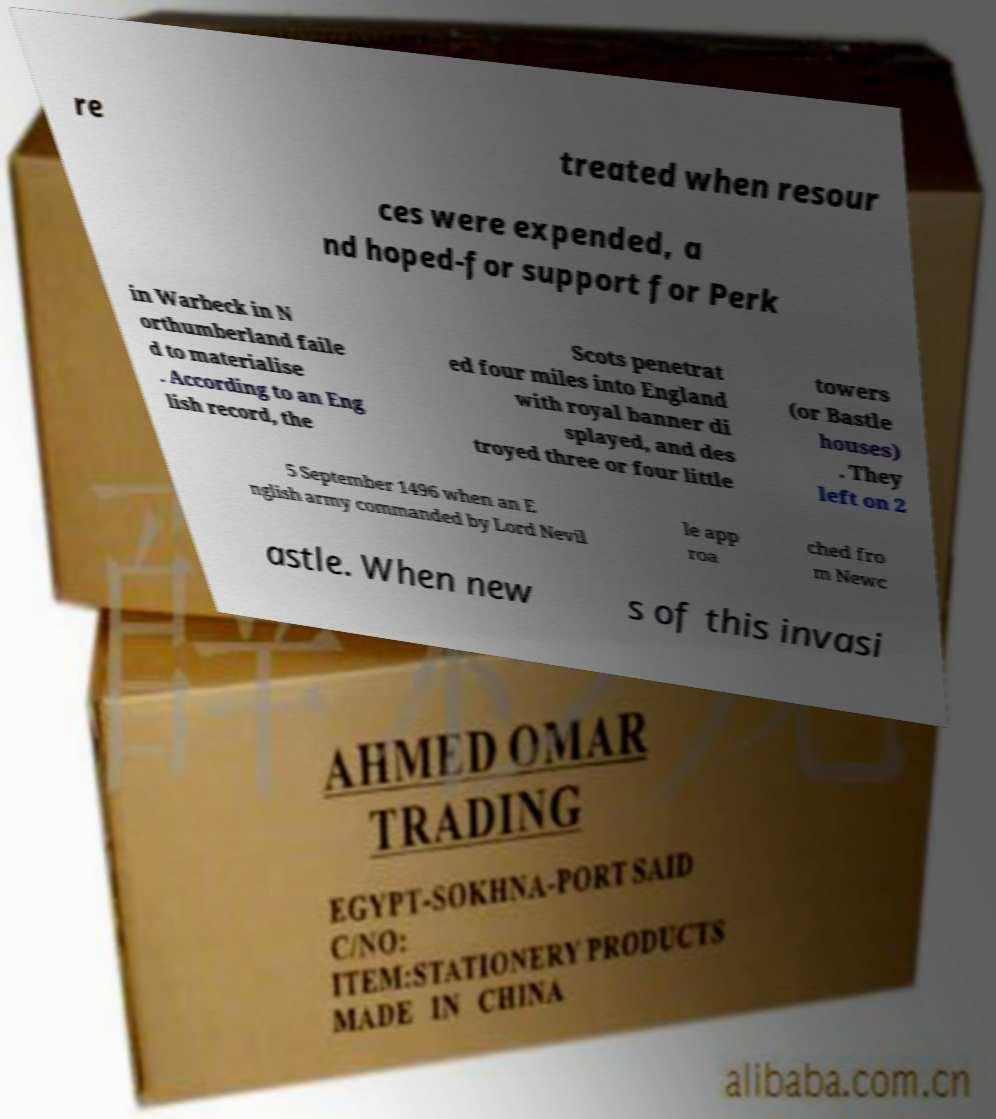I need the written content from this picture converted into text. Can you do that? re treated when resour ces were expended, a nd hoped-for support for Perk in Warbeck in N orthumberland faile d to materialise . According to an Eng lish record, the Scots penetrat ed four miles into England with royal banner di splayed, and des troyed three or four little towers (or Bastle houses) . They left on 2 5 September 1496 when an E nglish army commanded by Lord Nevil le app roa ched fro m Newc astle. When new s of this invasi 